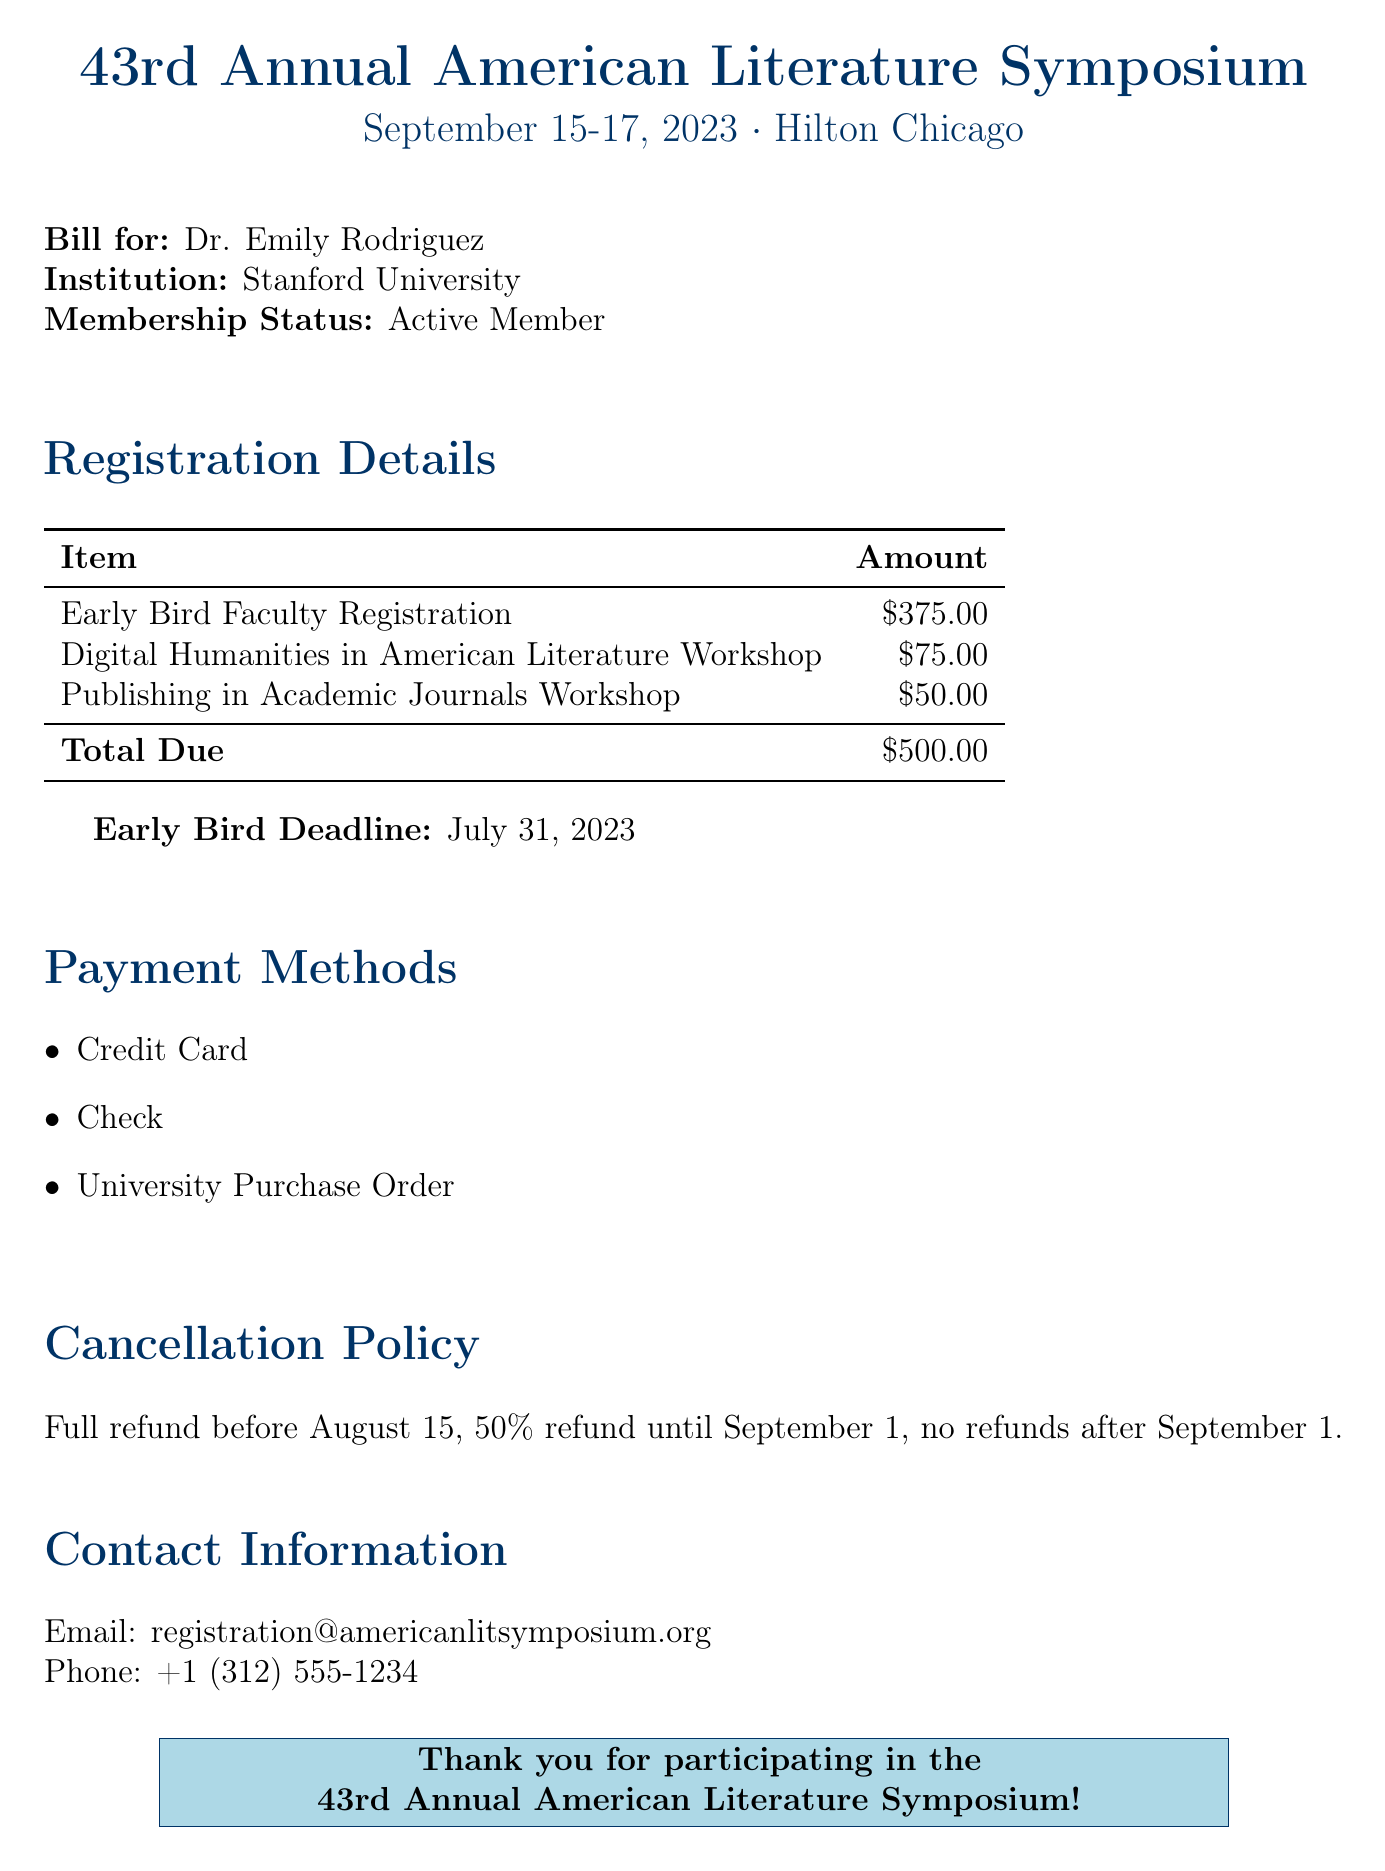What is the registration fee for early bird faculty? The document specifies the registration fee for early bird faculty, which is $375.00.
Answer: $375.00 What is the total amount due? The total amount due listed in the document is based on the registration fee and workshop charges, which sums up to $500.00.
Answer: $500.00 What is the date for the early bird deadline? The document states that the early bird deadline is July 31, 2023.
Answer: July 31, 2023 How much does the Digital Humanities workshop cost? The cost for the Digital Humanities in American Literature workshop is specified in the document as $75.00.
Answer: $75.00 What percentage refund is available until September 1? According to the cancellation policy in the document, a 50% refund is available until September 1.
Answer: 50% What is the email address for contact? The document provides the email address for contact as registration@americanlitsymposium.org.
Answer: registration@americanlitsymposium.org What is the refund policy after September 1? The document states that there are no refunds after September 1.
Answer: no refunds How much is the Publishing in Academic Journals workshop? The document lists the cost for the Publishing in Academic Journals workshop as $50.00.
Answer: $50.00 